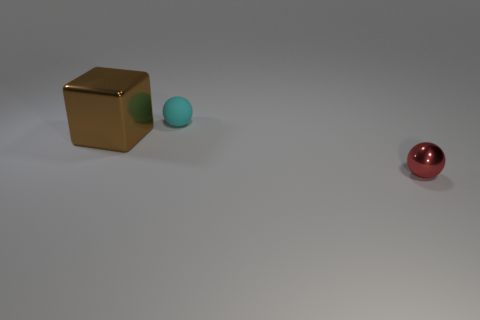Add 3 cubes. How many objects exist? 6 Subtract all blocks. How many objects are left? 2 Add 1 spheres. How many spheres exist? 3 Subtract 0 purple spheres. How many objects are left? 3 Subtract all big blue matte cylinders. Subtract all cyan balls. How many objects are left? 2 Add 3 tiny cyan objects. How many tiny cyan objects are left? 4 